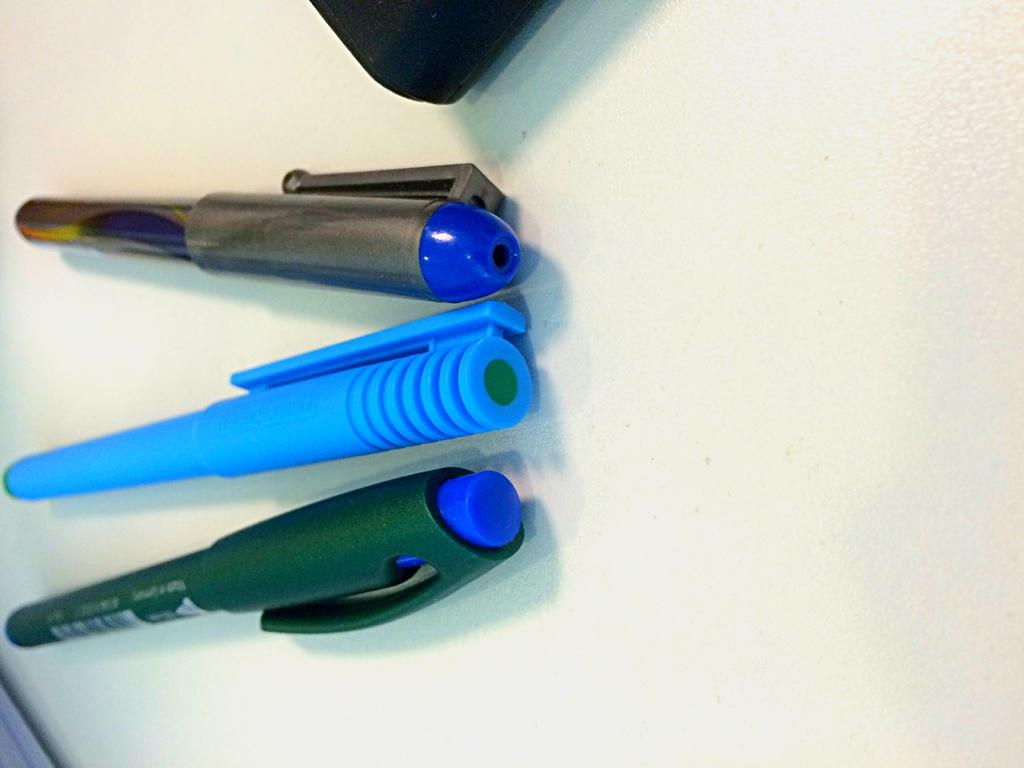How many pins are visible in the image? There are three pins in the image. What is the color of the pins? The pins are blue and green in color. On what surface are the pins placed? The pins are on a white surface. Are there any cacti visible in the image? No, there are no cacti present in the image. What type of fabric is used to make the pins in the image? The facts provided do not mention the material used to make the pins, so we cannot determine if they are made of silk or any other fabric. 